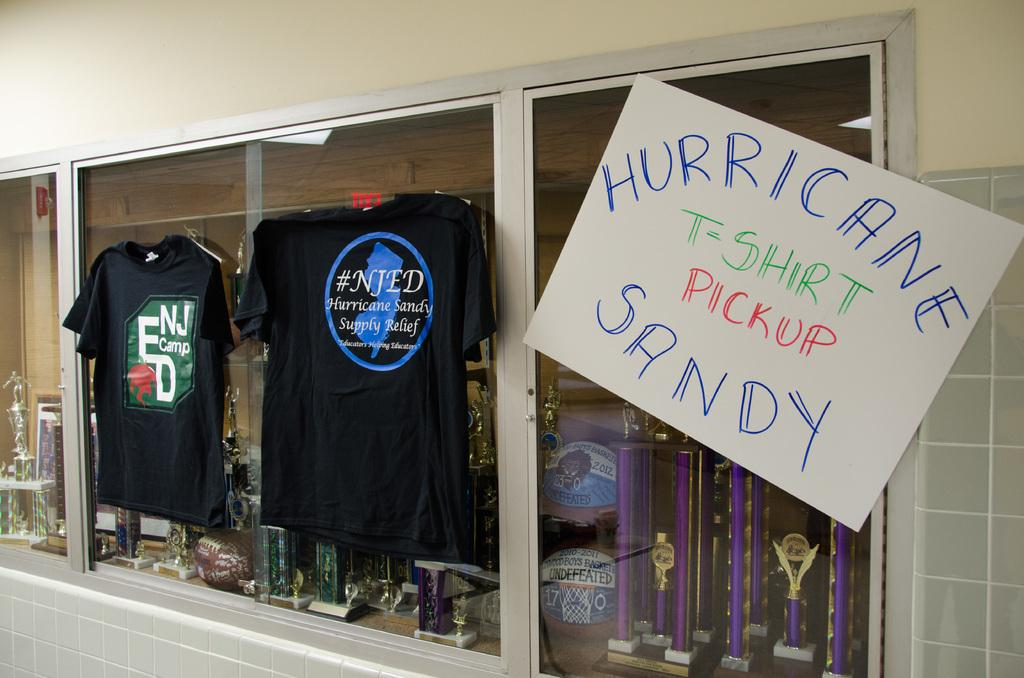Provide a one-sentence caption for the provided image. Trophy display with a sign on it that says t-shirt pickup for Hurricane Sandy. 